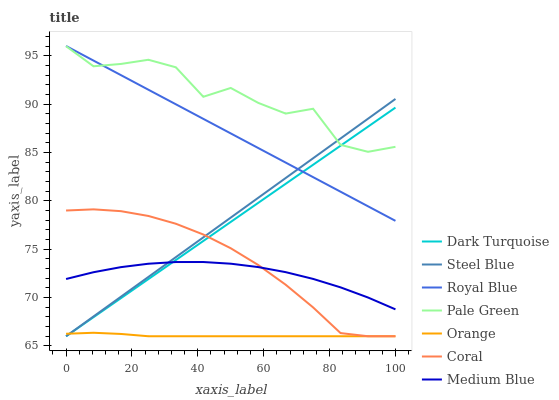Does Orange have the minimum area under the curve?
Answer yes or no. Yes. Does Pale Green have the maximum area under the curve?
Answer yes or no. Yes. Does Coral have the minimum area under the curve?
Answer yes or no. No. Does Coral have the maximum area under the curve?
Answer yes or no. No. Is Royal Blue the smoothest?
Answer yes or no. Yes. Is Pale Green the roughest?
Answer yes or no. Yes. Is Coral the smoothest?
Answer yes or no. No. Is Coral the roughest?
Answer yes or no. No. Does Dark Turquoise have the lowest value?
Answer yes or no. Yes. Does Medium Blue have the lowest value?
Answer yes or no. No. Does Royal Blue have the highest value?
Answer yes or no. Yes. Does Coral have the highest value?
Answer yes or no. No. Is Orange less than Pale Green?
Answer yes or no. Yes. Is Royal Blue greater than Medium Blue?
Answer yes or no. Yes. Does Medium Blue intersect Coral?
Answer yes or no. Yes. Is Medium Blue less than Coral?
Answer yes or no. No. Is Medium Blue greater than Coral?
Answer yes or no. No. Does Orange intersect Pale Green?
Answer yes or no. No. 